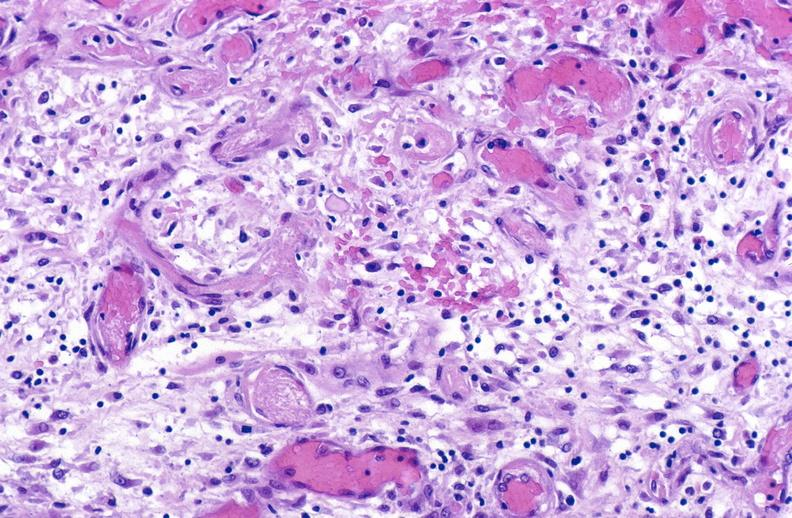what does this image show?
Answer the question using a single word or phrase. Tracheotomy site 